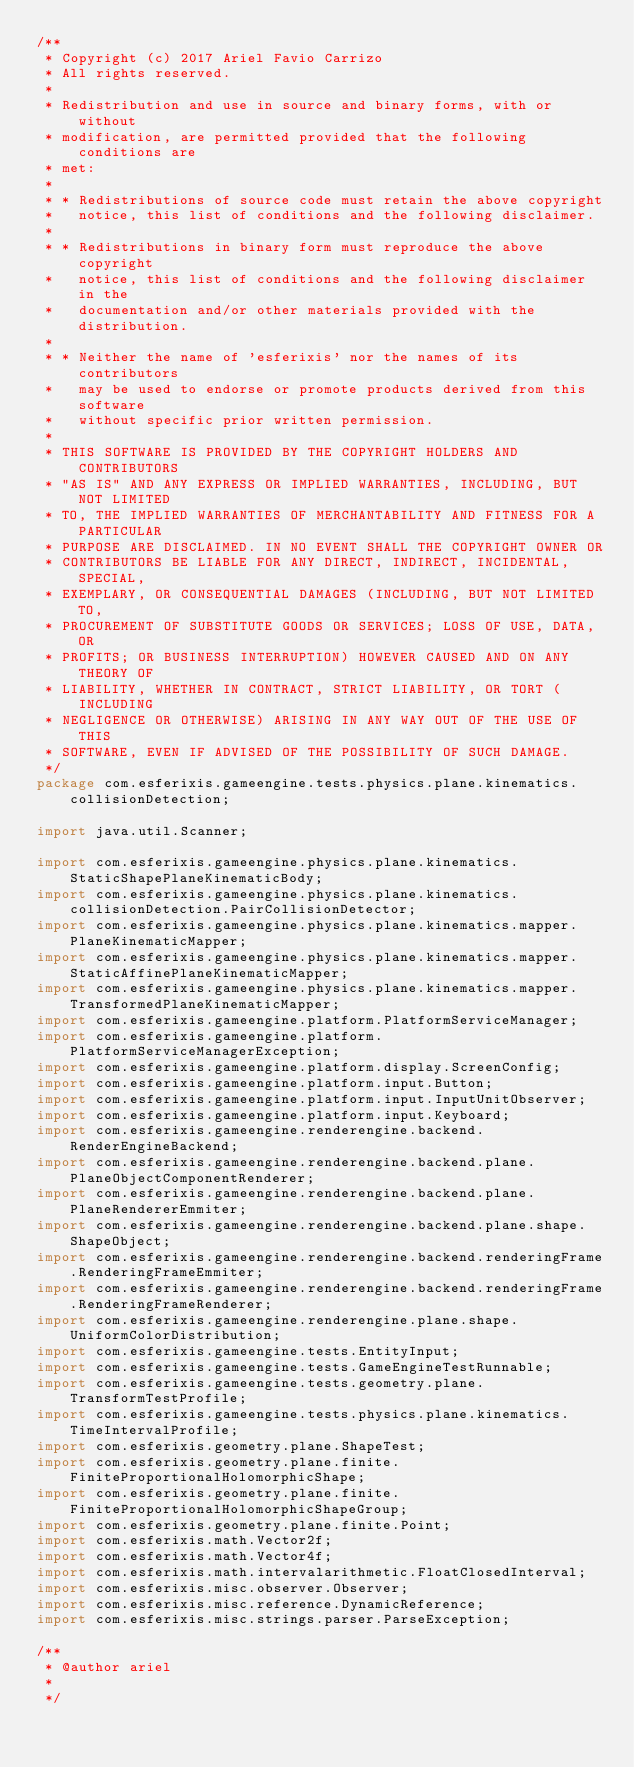Convert code to text. <code><loc_0><loc_0><loc_500><loc_500><_Java_>/**
 * Copyright (c) 2017 Ariel Favio Carrizo
 * All rights reserved.
 *
 * Redistribution and use in source and binary forms, with or without
 * modification, are permitted provided that the following conditions are
 * met:
 *
 * * Redistributions of source code must retain the above copyright
 *   notice, this list of conditions and the following disclaimer.
 *
 * * Redistributions in binary form must reproduce the above copyright
 *   notice, this list of conditions and the following disclaimer in the
 *   documentation and/or other materials provided with the distribution.
 *
 * * Neither the name of 'esferixis' nor the names of its contributors
 *   may be used to endorse or promote products derived from this software
 *   without specific prior written permission.
 *
 * THIS SOFTWARE IS PROVIDED BY THE COPYRIGHT HOLDERS AND CONTRIBUTORS
 * "AS IS" AND ANY EXPRESS OR IMPLIED WARRANTIES, INCLUDING, BUT NOT LIMITED
 * TO, THE IMPLIED WARRANTIES OF MERCHANTABILITY AND FITNESS FOR A PARTICULAR
 * PURPOSE ARE DISCLAIMED. IN NO EVENT SHALL THE COPYRIGHT OWNER OR
 * CONTRIBUTORS BE LIABLE FOR ANY DIRECT, INDIRECT, INCIDENTAL, SPECIAL,
 * EXEMPLARY, OR CONSEQUENTIAL DAMAGES (INCLUDING, BUT NOT LIMITED TO,
 * PROCUREMENT OF SUBSTITUTE GOODS OR SERVICES; LOSS OF USE, DATA, OR
 * PROFITS; OR BUSINESS INTERRUPTION) HOWEVER CAUSED AND ON ANY THEORY OF
 * LIABILITY, WHETHER IN CONTRACT, STRICT LIABILITY, OR TORT (INCLUDING
 * NEGLIGENCE OR OTHERWISE) ARISING IN ANY WAY OUT OF THE USE OF THIS
 * SOFTWARE, EVEN IF ADVISED OF THE POSSIBILITY OF SUCH DAMAGE.
 */
package com.esferixis.gameengine.tests.physics.plane.kinematics.collisionDetection;

import java.util.Scanner;

import com.esferixis.gameengine.physics.plane.kinematics.StaticShapePlaneKinematicBody;
import com.esferixis.gameengine.physics.plane.kinematics.collisionDetection.PairCollisionDetector;
import com.esferixis.gameengine.physics.plane.kinematics.mapper.PlaneKinematicMapper;
import com.esferixis.gameengine.physics.plane.kinematics.mapper.StaticAffinePlaneKinematicMapper;
import com.esferixis.gameengine.physics.plane.kinematics.mapper.TransformedPlaneKinematicMapper;
import com.esferixis.gameengine.platform.PlatformServiceManager;
import com.esferixis.gameengine.platform.PlatformServiceManagerException;
import com.esferixis.gameengine.platform.display.ScreenConfig;
import com.esferixis.gameengine.platform.input.Button;
import com.esferixis.gameengine.platform.input.InputUnitObserver;
import com.esferixis.gameengine.platform.input.Keyboard;
import com.esferixis.gameengine.renderengine.backend.RenderEngineBackend;
import com.esferixis.gameengine.renderengine.backend.plane.PlaneObjectComponentRenderer;
import com.esferixis.gameengine.renderengine.backend.plane.PlaneRendererEmmiter;
import com.esferixis.gameengine.renderengine.backend.plane.shape.ShapeObject;
import com.esferixis.gameengine.renderengine.backend.renderingFrame.RenderingFrameEmmiter;
import com.esferixis.gameengine.renderengine.backend.renderingFrame.RenderingFrameRenderer;
import com.esferixis.gameengine.renderengine.plane.shape.UniformColorDistribution;
import com.esferixis.gameengine.tests.EntityInput;
import com.esferixis.gameengine.tests.GameEngineTestRunnable;
import com.esferixis.gameengine.tests.geometry.plane.TransformTestProfile;
import com.esferixis.gameengine.tests.physics.plane.kinematics.TimeIntervalProfile;
import com.esferixis.geometry.plane.ShapeTest;
import com.esferixis.geometry.plane.finite.FiniteProportionalHolomorphicShape;
import com.esferixis.geometry.plane.finite.FiniteProportionalHolomorphicShapeGroup;
import com.esferixis.geometry.plane.finite.Point;
import com.esferixis.math.Vector2f;
import com.esferixis.math.Vector4f;
import com.esferixis.math.intervalarithmetic.FloatClosedInterval;
import com.esferixis.misc.observer.Observer;
import com.esferixis.misc.reference.DynamicReference;
import com.esferixis.misc.strings.parser.ParseException;

/**
 * @author ariel
 *
 */</code> 